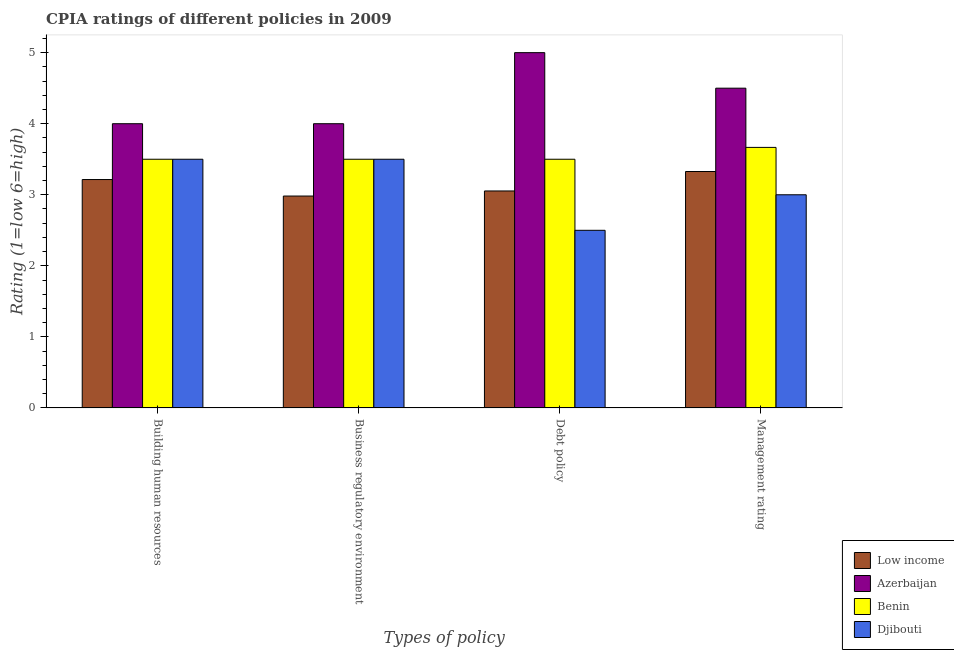How many groups of bars are there?
Your response must be concise. 4. Are the number of bars per tick equal to the number of legend labels?
Your response must be concise. Yes. How many bars are there on the 4th tick from the left?
Your answer should be compact. 4. What is the label of the 4th group of bars from the left?
Your response must be concise. Management rating. What is the cpia rating of business regulatory environment in Low income?
Ensure brevity in your answer.  2.98. Across all countries, what is the maximum cpia rating of business regulatory environment?
Provide a succinct answer. 4. In which country was the cpia rating of building human resources maximum?
Provide a succinct answer. Azerbaijan. In which country was the cpia rating of debt policy minimum?
Your response must be concise. Djibouti. What is the total cpia rating of business regulatory environment in the graph?
Your answer should be compact. 13.98. What is the difference between the cpia rating of management in Azerbaijan and that in Benin?
Provide a succinct answer. 0.83. What is the difference between the cpia rating of building human resources in Low income and the cpia rating of business regulatory environment in Benin?
Give a very brief answer. -0.29. What is the average cpia rating of debt policy per country?
Your response must be concise. 3.51. What is the difference between the cpia rating of business regulatory environment and cpia rating of debt policy in Benin?
Your response must be concise. 0. In how many countries, is the cpia rating of management greater than 0.4 ?
Your answer should be very brief. 4. What is the ratio of the cpia rating of business regulatory environment in Benin to that in Low income?
Keep it short and to the point. 1.17. Is the cpia rating of business regulatory environment in Low income less than that in Azerbaijan?
Your answer should be very brief. Yes. Is the difference between the cpia rating of management in Benin and Djibouti greater than the difference between the cpia rating of debt policy in Benin and Djibouti?
Your answer should be very brief. No. What is the difference between the highest and the second highest cpia rating of business regulatory environment?
Offer a terse response. 0.5. What does the 2nd bar from the left in Management rating represents?
Offer a terse response. Azerbaijan. What does the 2nd bar from the right in Debt policy represents?
Provide a succinct answer. Benin. How many countries are there in the graph?
Provide a short and direct response. 4. What is the difference between two consecutive major ticks on the Y-axis?
Your answer should be very brief. 1. Does the graph contain any zero values?
Your response must be concise. No. How are the legend labels stacked?
Provide a short and direct response. Vertical. What is the title of the graph?
Provide a succinct answer. CPIA ratings of different policies in 2009. Does "Paraguay" appear as one of the legend labels in the graph?
Offer a very short reply. No. What is the label or title of the X-axis?
Give a very brief answer. Types of policy. What is the label or title of the Y-axis?
Provide a succinct answer. Rating (1=low 6=high). What is the Rating (1=low 6=high) in Low income in Building human resources?
Your response must be concise. 3.21. What is the Rating (1=low 6=high) in Azerbaijan in Building human resources?
Your response must be concise. 4. What is the Rating (1=low 6=high) of Low income in Business regulatory environment?
Keep it short and to the point. 2.98. What is the Rating (1=low 6=high) of Benin in Business regulatory environment?
Your response must be concise. 3.5. What is the Rating (1=low 6=high) of Low income in Debt policy?
Give a very brief answer. 3.05. What is the Rating (1=low 6=high) of Low income in Management rating?
Your response must be concise. 3.33. What is the Rating (1=low 6=high) in Benin in Management rating?
Offer a terse response. 3.67. What is the Rating (1=low 6=high) in Djibouti in Management rating?
Provide a succinct answer. 3. Across all Types of policy, what is the maximum Rating (1=low 6=high) of Low income?
Offer a very short reply. 3.33. Across all Types of policy, what is the maximum Rating (1=low 6=high) of Azerbaijan?
Keep it short and to the point. 5. Across all Types of policy, what is the maximum Rating (1=low 6=high) of Benin?
Your answer should be very brief. 3.67. Across all Types of policy, what is the minimum Rating (1=low 6=high) in Low income?
Give a very brief answer. 2.98. Across all Types of policy, what is the minimum Rating (1=low 6=high) of Azerbaijan?
Offer a very short reply. 4. What is the total Rating (1=low 6=high) in Low income in the graph?
Your answer should be compact. 12.58. What is the total Rating (1=low 6=high) in Benin in the graph?
Offer a very short reply. 14.17. What is the total Rating (1=low 6=high) in Djibouti in the graph?
Your answer should be very brief. 12.5. What is the difference between the Rating (1=low 6=high) of Low income in Building human resources and that in Business regulatory environment?
Provide a short and direct response. 0.23. What is the difference between the Rating (1=low 6=high) of Azerbaijan in Building human resources and that in Business regulatory environment?
Provide a succinct answer. 0. What is the difference between the Rating (1=low 6=high) in Benin in Building human resources and that in Business regulatory environment?
Your answer should be compact. 0. What is the difference between the Rating (1=low 6=high) of Low income in Building human resources and that in Debt policy?
Your answer should be compact. 0.16. What is the difference between the Rating (1=low 6=high) in Low income in Building human resources and that in Management rating?
Your answer should be very brief. -0.11. What is the difference between the Rating (1=low 6=high) of Azerbaijan in Building human resources and that in Management rating?
Give a very brief answer. -0.5. What is the difference between the Rating (1=low 6=high) in Low income in Business regulatory environment and that in Debt policy?
Keep it short and to the point. -0.07. What is the difference between the Rating (1=low 6=high) in Azerbaijan in Business regulatory environment and that in Debt policy?
Offer a terse response. -1. What is the difference between the Rating (1=low 6=high) in Low income in Business regulatory environment and that in Management rating?
Provide a short and direct response. -0.35. What is the difference between the Rating (1=low 6=high) in Benin in Business regulatory environment and that in Management rating?
Ensure brevity in your answer.  -0.17. What is the difference between the Rating (1=low 6=high) of Djibouti in Business regulatory environment and that in Management rating?
Offer a terse response. 0.5. What is the difference between the Rating (1=low 6=high) in Low income in Debt policy and that in Management rating?
Your answer should be very brief. -0.27. What is the difference between the Rating (1=low 6=high) of Azerbaijan in Debt policy and that in Management rating?
Offer a very short reply. 0.5. What is the difference between the Rating (1=low 6=high) in Djibouti in Debt policy and that in Management rating?
Provide a succinct answer. -0.5. What is the difference between the Rating (1=low 6=high) of Low income in Building human resources and the Rating (1=low 6=high) of Azerbaijan in Business regulatory environment?
Your answer should be compact. -0.79. What is the difference between the Rating (1=low 6=high) in Low income in Building human resources and the Rating (1=low 6=high) in Benin in Business regulatory environment?
Your answer should be very brief. -0.29. What is the difference between the Rating (1=low 6=high) of Low income in Building human resources and the Rating (1=low 6=high) of Djibouti in Business regulatory environment?
Provide a short and direct response. -0.29. What is the difference between the Rating (1=low 6=high) of Azerbaijan in Building human resources and the Rating (1=low 6=high) of Djibouti in Business regulatory environment?
Keep it short and to the point. 0.5. What is the difference between the Rating (1=low 6=high) in Low income in Building human resources and the Rating (1=low 6=high) in Azerbaijan in Debt policy?
Provide a succinct answer. -1.79. What is the difference between the Rating (1=low 6=high) in Low income in Building human resources and the Rating (1=low 6=high) in Benin in Debt policy?
Make the answer very short. -0.29. What is the difference between the Rating (1=low 6=high) of Azerbaijan in Building human resources and the Rating (1=low 6=high) of Benin in Debt policy?
Offer a very short reply. 0.5. What is the difference between the Rating (1=low 6=high) of Benin in Building human resources and the Rating (1=low 6=high) of Djibouti in Debt policy?
Your response must be concise. 1. What is the difference between the Rating (1=low 6=high) of Low income in Building human resources and the Rating (1=low 6=high) of Azerbaijan in Management rating?
Offer a very short reply. -1.29. What is the difference between the Rating (1=low 6=high) in Low income in Building human resources and the Rating (1=low 6=high) in Benin in Management rating?
Your answer should be very brief. -0.45. What is the difference between the Rating (1=low 6=high) of Low income in Building human resources and the Rating (1=low 6=high) of Djibouti in Management rating?
Make the answer very short. 0.21. What is the difference between the Rating (1=low 6=high) in Benin in Building human resources and the Rating (1=low 6=high) in Djibouti in Management rating?
Provide a short and direct response. 0.5. What is the difference between the Rating (1=low 6=high) of Low income in Business regulatory environment and the Rating (1=low 6=high) of Azerbaijan in Debt policy?
Offer a terse response. -2.02. What is the difference between the Rating (1=low 6=high) of Low income in Business regulatory environment and the Rating (1=low 6=high) of Benin in Debt policy?
Your answer should be very brief. -0.52. What is the difference between the Rating (1=low 6=high) of Low income in Business regulatory environment and the Rating (1=low 6=high) of Djibouti in Debt policy?
Provide a succinct answer. 0.48. What is the difference between the Rating (1=low 6=high) in Benin in Business regulatory environment and the Rating (1=low 6=high) in Djibouti in Debt policy?
Your response must be concise. 1. What is the difference between the Rating (1=low 6=high) of Low income in Business regulatory environment and the Rating (1=low 6=high) of Azerbaijan in Management rating?
Your answer should be compact. -1.52. What is the difference between the Rating (1=low 6=high) in Low income in Business regulatory environment and the Rating (1=low 6=high) in Benin in Management rating?
Your response must be concise. -0.68. What is the difference between the Rating (1=low 6=high) of Low income in Business regulatory environment and the Rating (1=low 6=high) of Djibouti in Management rating?
Your answer should be very brief. -0.02. What is the difference between the Rating (1=low 6=high) of Benin in Business regulatory environment and the Rating (1=low 6=high) of Djibouti in Management rating?
Keep it short and to the point. 0.5. What is the difference between the Rating (1=low 6=high) of Low income in Debt policy and the Rating (1=low 6=high) of Azerbaijan in Management rating?
Your answer should be very brief. -1.45. What is the difference between the Rating (1=low 6=high) in Low income in Debt policy and the Rating (1=low 6=high) in Benin in Management rating?
Offer a very short reply. -0.61. What is the difference between the Rating (1=low 6=high) in Low income in Debt policy and the Rating (1=low 6=high) in Djibouti in Management rating?
Offer a very short reply. 0.05. What is the difference between the Rating (1=low 6=high) in Azerbaijan in Debt policy and the Rating (1=low 6=high) in Djibouti in Management rating?
Offer a terse response. 2. What is the average Rating (1=low 6=high) in Low income per Types of policy?
Give a very brief answer. 3.14. What is the average Rating (1=low 6=high) in Azerbaijan per Types of policy?
Provide a short and direct response. 4.38. What is the average Rating (1=low 6=high) in Benin per Types of policy?
Ensure brevity in your answer.  3.54. What is the average Rating (1=low 6=high) in Djibouti per Types of policy?
Your answer should be compact. 3.12. What is the difference between the Rating (1=low 6=high) in Low income and Rating (1=low 6=high) in Azerbaijan in Building human resources?
Provide a succinct answer. -0.79. What is the difference between the Rating (1=low 6=high) in Low income and Rating (1=low 6=high) in Benin in Building human resources?
Ensure brevity in your answer.  -0.29. What is the difference between the Rating (1=low 6=high) in Low income and Rating (1=low 6=high) in Djibouti in Building human resources?
Ensure brevity in your answer.  -0.29. What is the difference between the Rating (1=low 6=high) of Azerbaijan and Rating (1=low 6=high) of Benin in Building human resources?
Make the answer very short. 0.5. What is the difference between the Rating (1=low 6=high) of Benin and Rating (1=low 6=high) of Djibouti in Building human resources?
Offer a terse response. 0. What is the difference between the Rating (1=low 6=high) in Low income and Rating (1=low 6=high) in Azerbaijan in Business regulatory environment?
Provide a succinct answer. -1.02. What is the difference between the Rating (1=low 6=high) of Low income and Rating (1=low 6=high) of Benin in Business regulatory environment?
Provide a succinct answer. -0.52. What is the difference between the Rating (1=low 6=high) in Low income and Rating (1=low 6=high) in Djibouti in Business regulatory environment?
Your response must be concise. -0.52. What is the difference between the Rating (1=low 6=high) of Low income and Rating (1=low 6=high) of Azerbaijan in Debt policy?
Make the answer very short. -1.95. What is the difference between the Rating (1=low 6=high) in Low income and Rating (1=low 6=high) in Benin in Debt policy?
Offer a very short reply. -0.45. What is the difference between the Rating (1=low 6=high) of Low income and Rating (1=low 6=high) of Djibouti in Debt policy?
Offer a very short reply. 0.55. What is the difference between the Rating (1=low 6=high) of Azerbaijan and Rating (1=low 6=high) of Djibouti in Debt policy?
Keep it short and to the point. 2.5. What is the difference between the Rating (1=low 6=high) of Low income and Rating (1=low 6=high) of Azerbaijan in Management rating?
Provide a short and direct response. -1.17. What is the difference between the Rating (1=low 6=high) in Low income and Rating (1=low 6=high) in Benin in Management rating?
Provide a short and direct response. -0.34. What is the difference between the Rating (1=low 6=high) in Low income and Rating (1=low 6=high) in Djibouti in Management rating?
Give a very brief answer. 0.33. What is the difference between the Rating (1=low 6=high) in Benin and Rating (1=low 6=high) in Djibouti in Management rating?
Keep it short and to the point. 0.67. What is the ratio of the Rating (1=low 6=high) in Low income in Building human resources to that in Business regulatory environment?
Keep it short and to the point. 1.08. What is the ratio of the Rating (1=low 6=high) in Benin in Building human resources to that in Business regulatory environment?
Provide a short and direct response. 1. What is the ratio of the Rating (1=low 6=high) in Low income in Building human resources to that in Debt policy?
Provide a succinct answer. 1.05. What is the ratio of the Rating (1=low 6=high) of Azerbaijan in Building human resources to that in Debt policy?
Provide a succinct answer. 0.8. What is the ratio of the Rating (1=low 6=high) in Benin in Building human resources to that in Debt policy?
Provide a short and direct response. 1. What is the ratio of the Rating (1=low 6=high) in Djibouti in Building human resources to that in Debt policy?
Keep it short and to the point. 1.4. What is the ratio of the Rating (1=low 6=high) of Benin in Building human resources to that in Management rating?
Your answer should be very brief. 0.95. What is the ratio of the Rating (1=low 6=high) in Djibouti in Building human resources to that in Management rating?
Give a very brief answer. 1.17. What is the ratio of the Rating (1=low 6=high) in Low income in Business regulatory environment to that in Debt policy?
Offer a very short reply. 0.98. What is the ratio of the Rating (1=low 6=high) in Azerbaijan in Business regulatory environment to that in Debt policy?
Ensure brevity in your answer.  0.8. What is the ratio of the Rating (1=low 6=high) in Djibouti in Business regulatory environment to that in Debt policy?
Make the answer very short. 1.4. What is the ratio of the Rating (1=low 6=high) in Low income in Business regulatory environment to that in Management rating?
Give a very brief answer. 0.9. What is the ratio of the Rating (1=low 6=high) of Azerbaijan in Business regulatory environment to that in Management rating?
Your response must be concise. 0.89. What is the ratio of the Rating (1=low 6=high) in Benin in Business regulatory environment to that in Management rating?
Your response must be concise. 0.95. What is the ratio of the Rating (1=low 6=high) in Low income in Debt policy to that in Management rating?
Provide a short and direct response. 0.92. What is the ratio of the Rating (1=low 6=high) of Benin in Debt policy to that in Management rating?
Give a very brief answer. 0.95. What is the difference between the highest and the second highest Rating (1=low 6=high) in Low income?
Provide a succinct answer. 0.11. What is the difference between the highest and the second highest Rating (1=low 6=high) of Azerbaijan?
Your answer should be very brief. 0.5. What is the difference between the highest and the second highest Rating (1=low 6=high) in Benin?
Your answer should be compact. 0.17. What is the difference between the highest and the lowest Rating (1=low 6=high) of Low income?
Provide a short and direct response. 0.35. What is the difference between the highest and the lowest Rating (1=low 6=high) of Benin?
Offer a terse response. 0.17. 